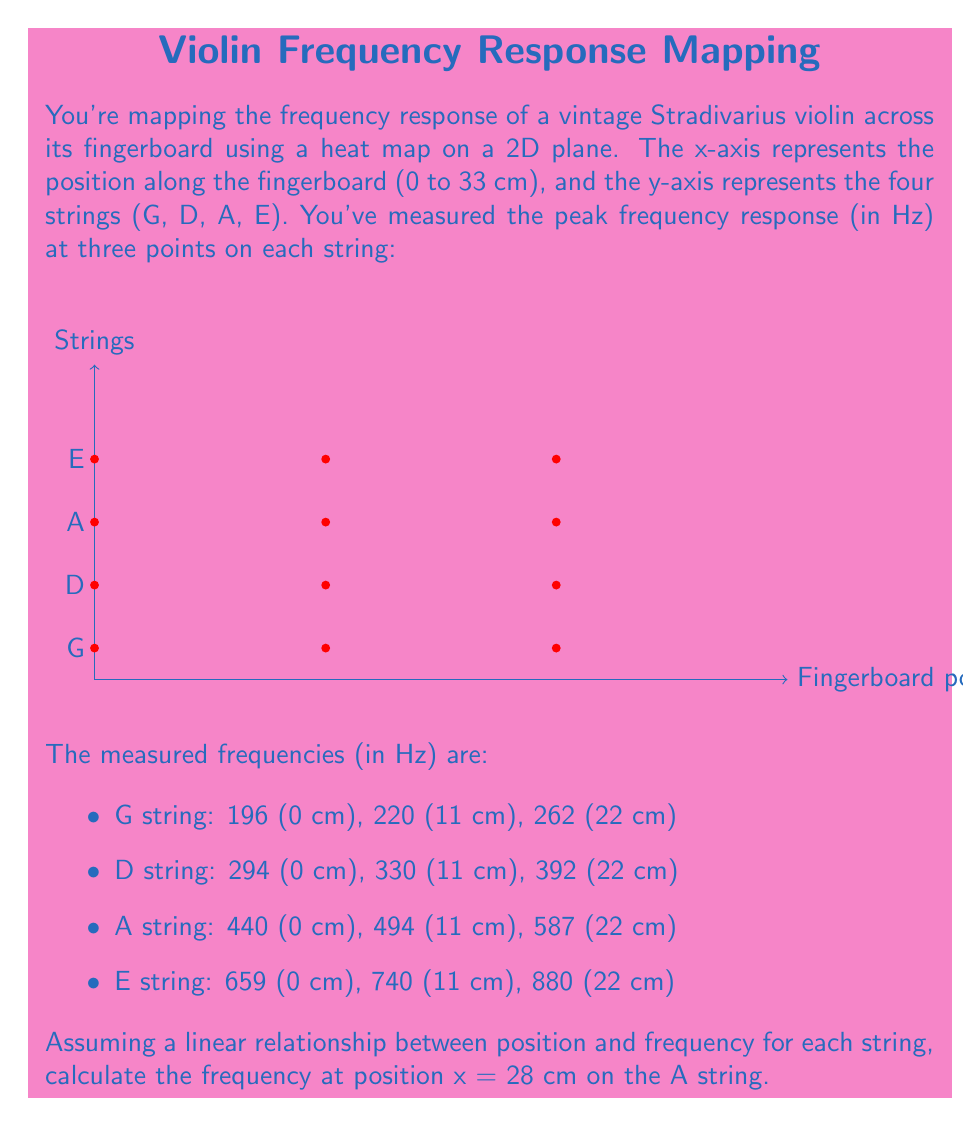Can you answer this question? To solve this problem, we'll follow these steps:

1) First, we need to understand that we're dealing with a linear relationship between position and frequency for each string. This means we can use the point-slope form of a line equation.

2) For the A string, we have three points: (0, 440), (11, 494), and (22, 587). We'll use the first and last points to find the slope of the line.

3) The slope (m) can be calculated using the formula:

   $$m = \frac{y_2 - y_1}{x_2 - x_1} = \frac{587 - 440}{22 - 0} = \frac{147}{22} \approx 6.68$$

4) Now that we have the slope, we can use the point-slope form of a line equation:

   $$y - y_1 = m(x - x_1)$$

   Where $(x_1, y_1)$ is a known point on the line. Let's use (0, 440).

5) Substituting our values:

   $$y - 440 = 6.68(x - 0)$$

6) Simplify:

   $$y = 6.68x + 440$$

7) Now, we want to find y when x = 28. Let's substitute x = 28 into our equation:

   $$y = 6.68(28) + 440$$

8) Calculate:

   $$y = 187.04 + 440 = 627.04$$

Therefore, at x = 28 cm on the A string, the frequency is approximately 627.04 Hz.
Answer: 627.04 Hz 